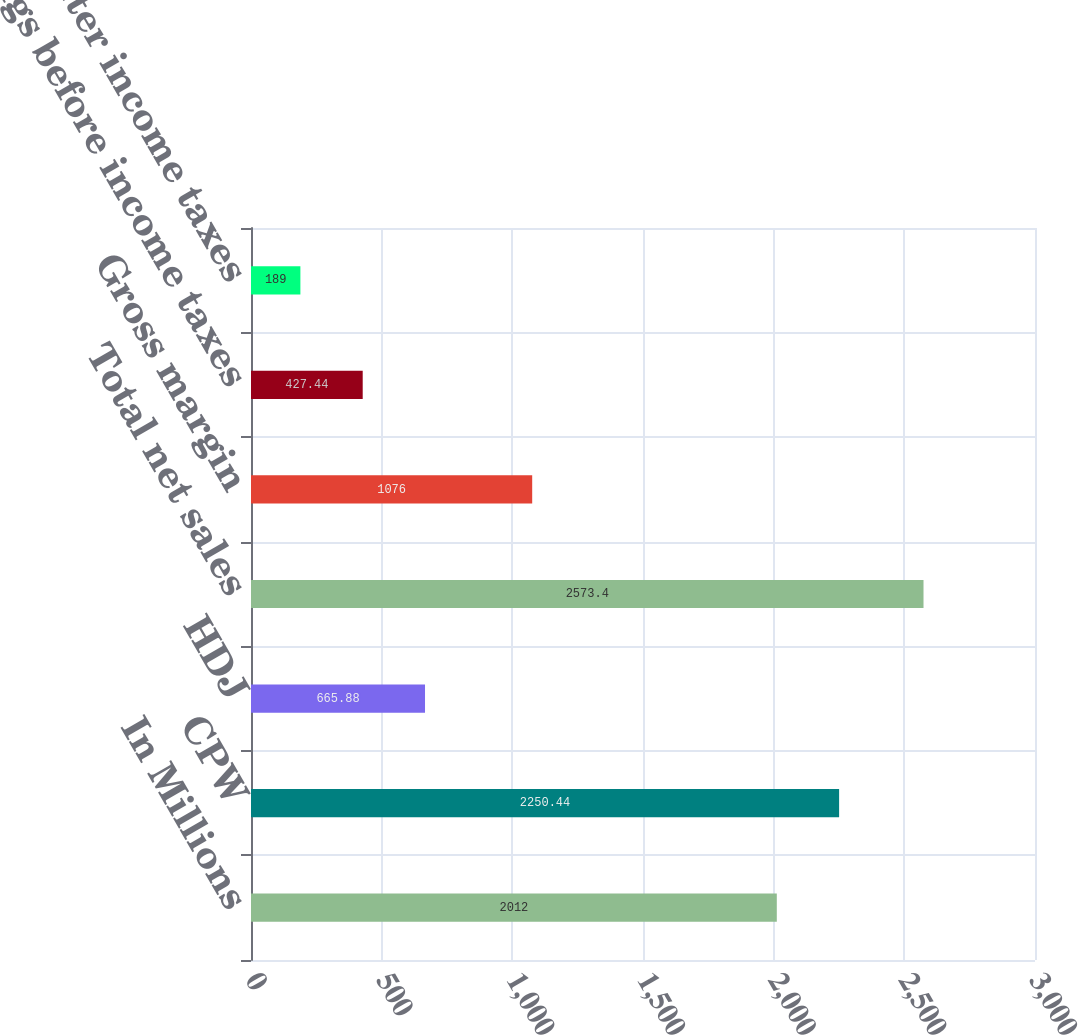<chart> <loc_0><loc_0><loc_500><loc_500><bar_chart><fcel>In Millions<fcel>CPW<fcel>HDJ<fcel>Total net sales<fcel>Gross margin<fcel>Earnings before income taxes<fcel>Earnings after income taxes<nl><fcel>2012<fcel>2250.44<fcel>665.88<fcel>2573.4<fcel>1076<fcel>427.44<fcel>189<nl></chart> 